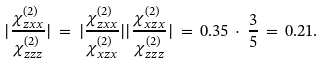Convert formula to latex. <formula><loc_0><loc_0><loc_500><loc_500>| \frac { \chi _ { z x x } ^ { ( 2 ) } } { \chi _ { z z z } ^ { ( 2 ) } } | \, = \, | \frac { \chi _ { z x x } ^ { ( 2 ) } } { \chi _ { x z x } ^ { ( 2 ) } } | | \frac { \chi _ { x z x } ^ { ( 2 ) } } { \chi _ { z z z } ^ { ( 2 ) } } | \, = \, 0 . 3 5 \, \cdot \, \frac { 3 } { 5 } \, = \, 0 . 2 1 .</formula> 